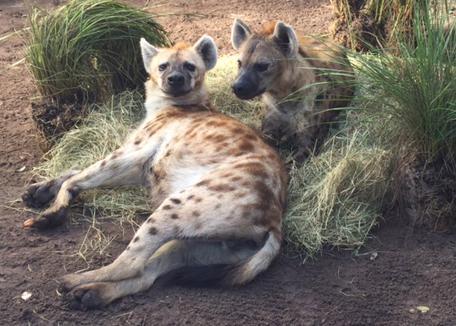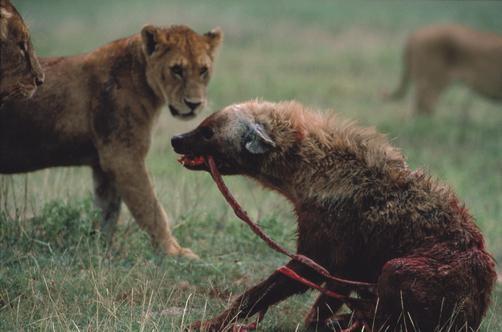The first image is the image on the left, the second image is the image on the right. For the images shown, is this caption "Contains a picture with more than 1 Hyena." true? Answer yes or no. Yes. The first image is the image on the left, the second image is the image on the right. Analyze the images presented: Is the assertion "Cheetahs are attacking an elephant on the ground in the image on the right." valid? Answer yes or no. No. 